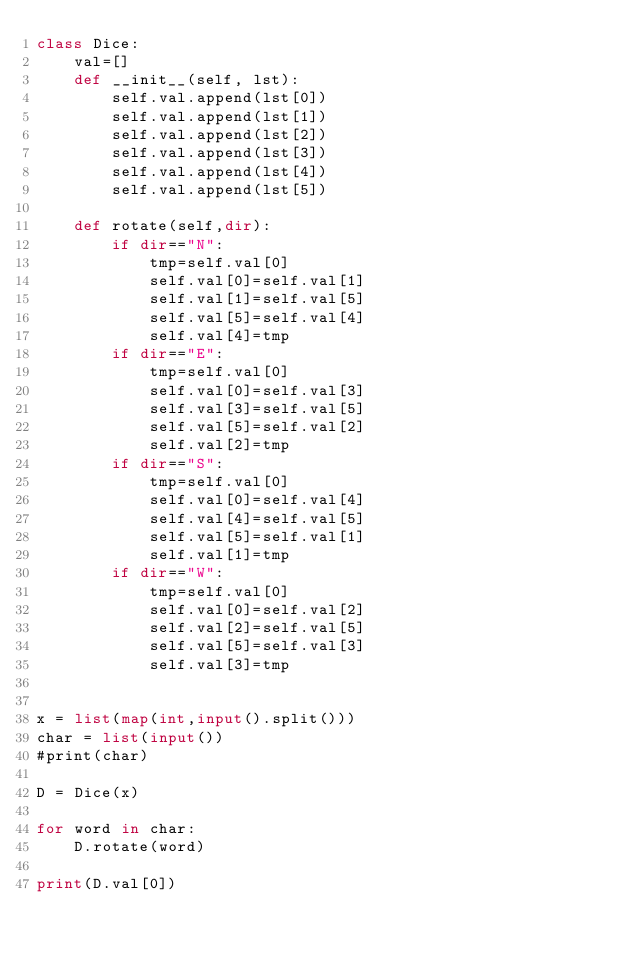<code> <loc_0><loc_0><loc_500><loc_500><_Python_>class Dice:
    val=[]
    def __init__(self, lst):
        self.val.append(lst[0])
        self.val.append(lst[1])
        self.val.append(lst[2])
        self.val.append(lst[3])
        self.val.append(lst[4])
        self.val.append(lst[5])

    def rotate(self,dir):
        if dir=="N":
            tmp=self.val[0]
            self.val[0]=self.val[1]
            self.val[1]=self.val[5]
            self.val[5]=self.val[4]
            self.val[4]=tmp
        if dir=="E":
            tmp=self.val[0]
            self.val[0]=self.val[3]
            self.val[3]=self.val[5]
            self.val[5]=self.val[2]
            self.val[2]=tmp
        if dir=="S":
            tmp=self.val[0]
            self.val[0]=self.val[4]
            self.val[4]=self.val[5]
            self.val[5]=self.val[1]
            self.val[1]=tmp
        if dir=="W":
            tmp=self.val[0]
            self.val[0]=self.val[2]
            self.val[2]=self.val[5]
            self.val[5]=self.val[3]
            self.val[3]=tmp


x = list(map(int,input().split()))
char = list(input())
#print(char)

D = Dice(x)

for word in char:
    D.rotate(word)

print(D.val[0])

</code> 